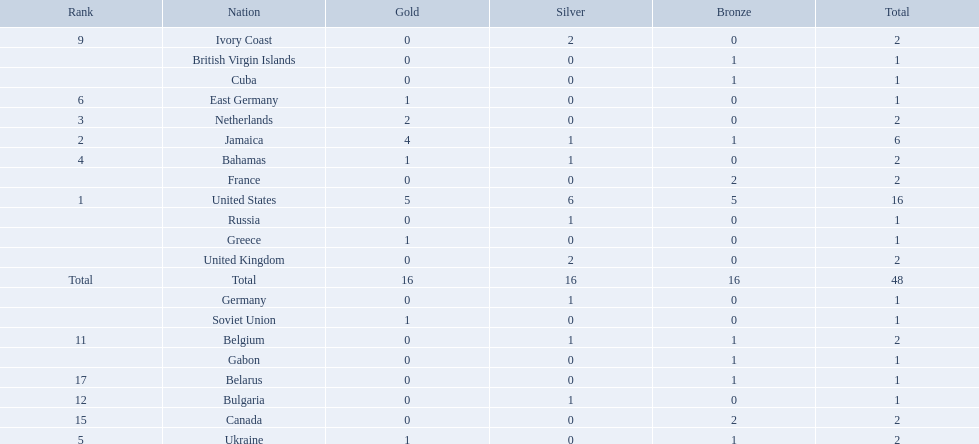Which countries participated? United States, Jamaica, Netherlands, Bahamas, Ukraine, East Germany, Greece, Soviet Union, Ivory Coast, United Kingdom, Belgium, Bulgaria, Russia, Germany, Canada, France, Belarus, Cuba, Gabon, British Virgin Islands. How many gold medals were won by each? 5, 4, 2, 1, 1, 1, 1, 1, 0, 0, 0, 0, 0, 0, 0, 0, 0, 0, 0, 0. And which country won the most? United States. Which nations took home at least one gold medal in the 60 metres competition? United States, Jamaica, Netherlands, Bahamas, Ukraine, East Germany, Greece, Soviet Union. Of these nations, which one won the most gold medals? United States. 